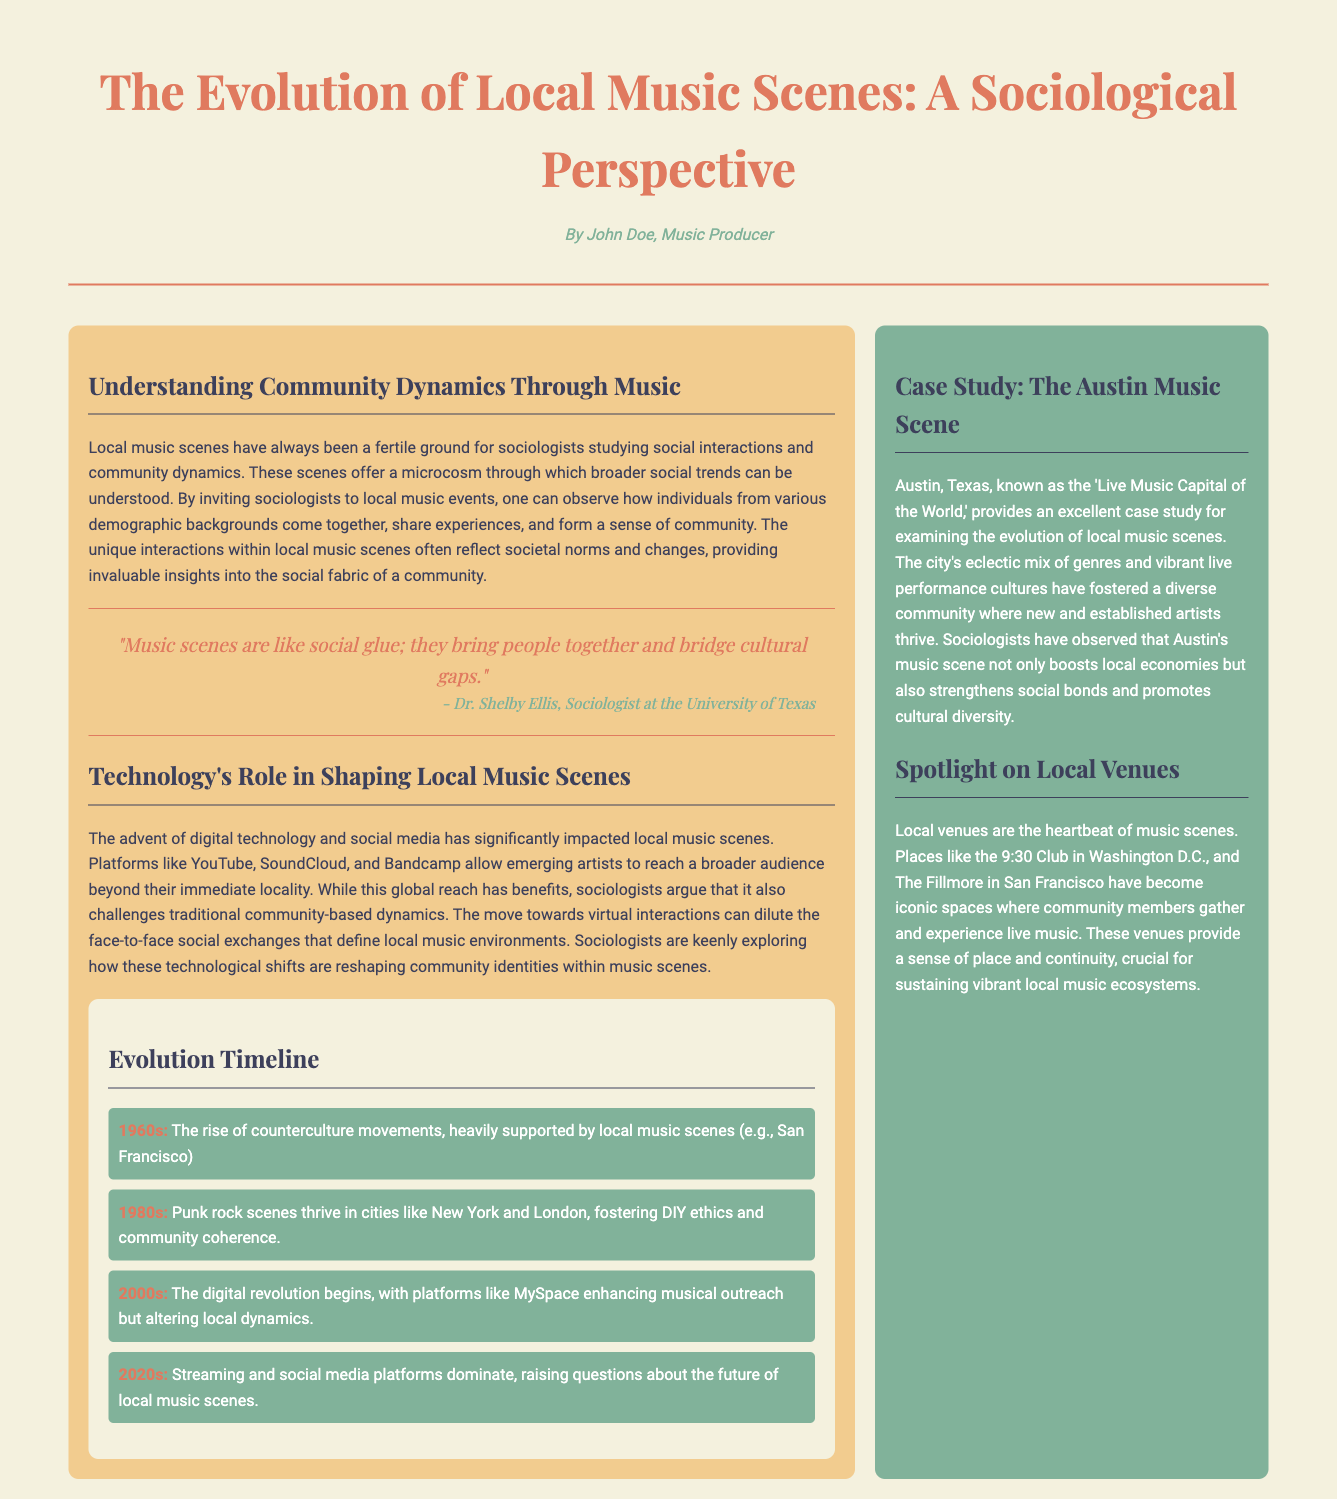What is the title of the article? The title of the article is explicitly stated in the header of the document.
Answer: The Evolution of Local Music Scenes: A Sociological Perspective Who is the author of the article? The author is mentioned in the byline directly under the title.
Answer: John Doe What decade is associated with the rise of counterculture movements? The document specifies a decade in the timeline section related to counterculture movements.
Answer: 1960s What role does technology play according to the article? The document discusses technology's impact on local music scenes, specifically in terms of digital platforms.
Answer: Shaping local music scenes Which city is referred to as the 'Live Music Capital of the World'? The sidebar contains information identifying a specific city with this title.
Answer: Austin, Texas What type of venues are highlighted in the sidebar? The sidebar section discusses types of venues key to local music scenes.
Answer: Local venues What is highlighted as a significant trend in the 2020s? The timeline segment addresses changes in local music scenes during this decade.
Answer: Streaming and social media platforms dominate Who is quoted about music scenes serving as social glue? The quote section attributes a statement about music scenes to a specific person.
Answer: Dr. Shelby Ellis 